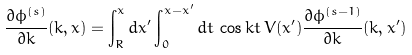<formula> <loc_0><loc_0><loc_500><loc_500>\frac { \partial \phi ^ { ( s ) } } { \partial k } ( k , x ) = \int _ { R } ^ { x } d x ^ { \prime } \int _ { 0 } ^ { x - x ^ { \prime } } d t \, \cos k t \, V ( x ^ { \prime } ) \frac { \partial \phi ^ { ( s - 1 ) } } { \partial k } ( k , x ^ { \prime } )</formula> 